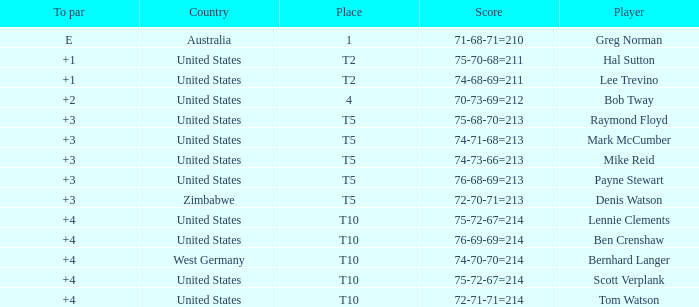Can you identify the player with a score of 75-68-70=213? Raymond Floyd. 